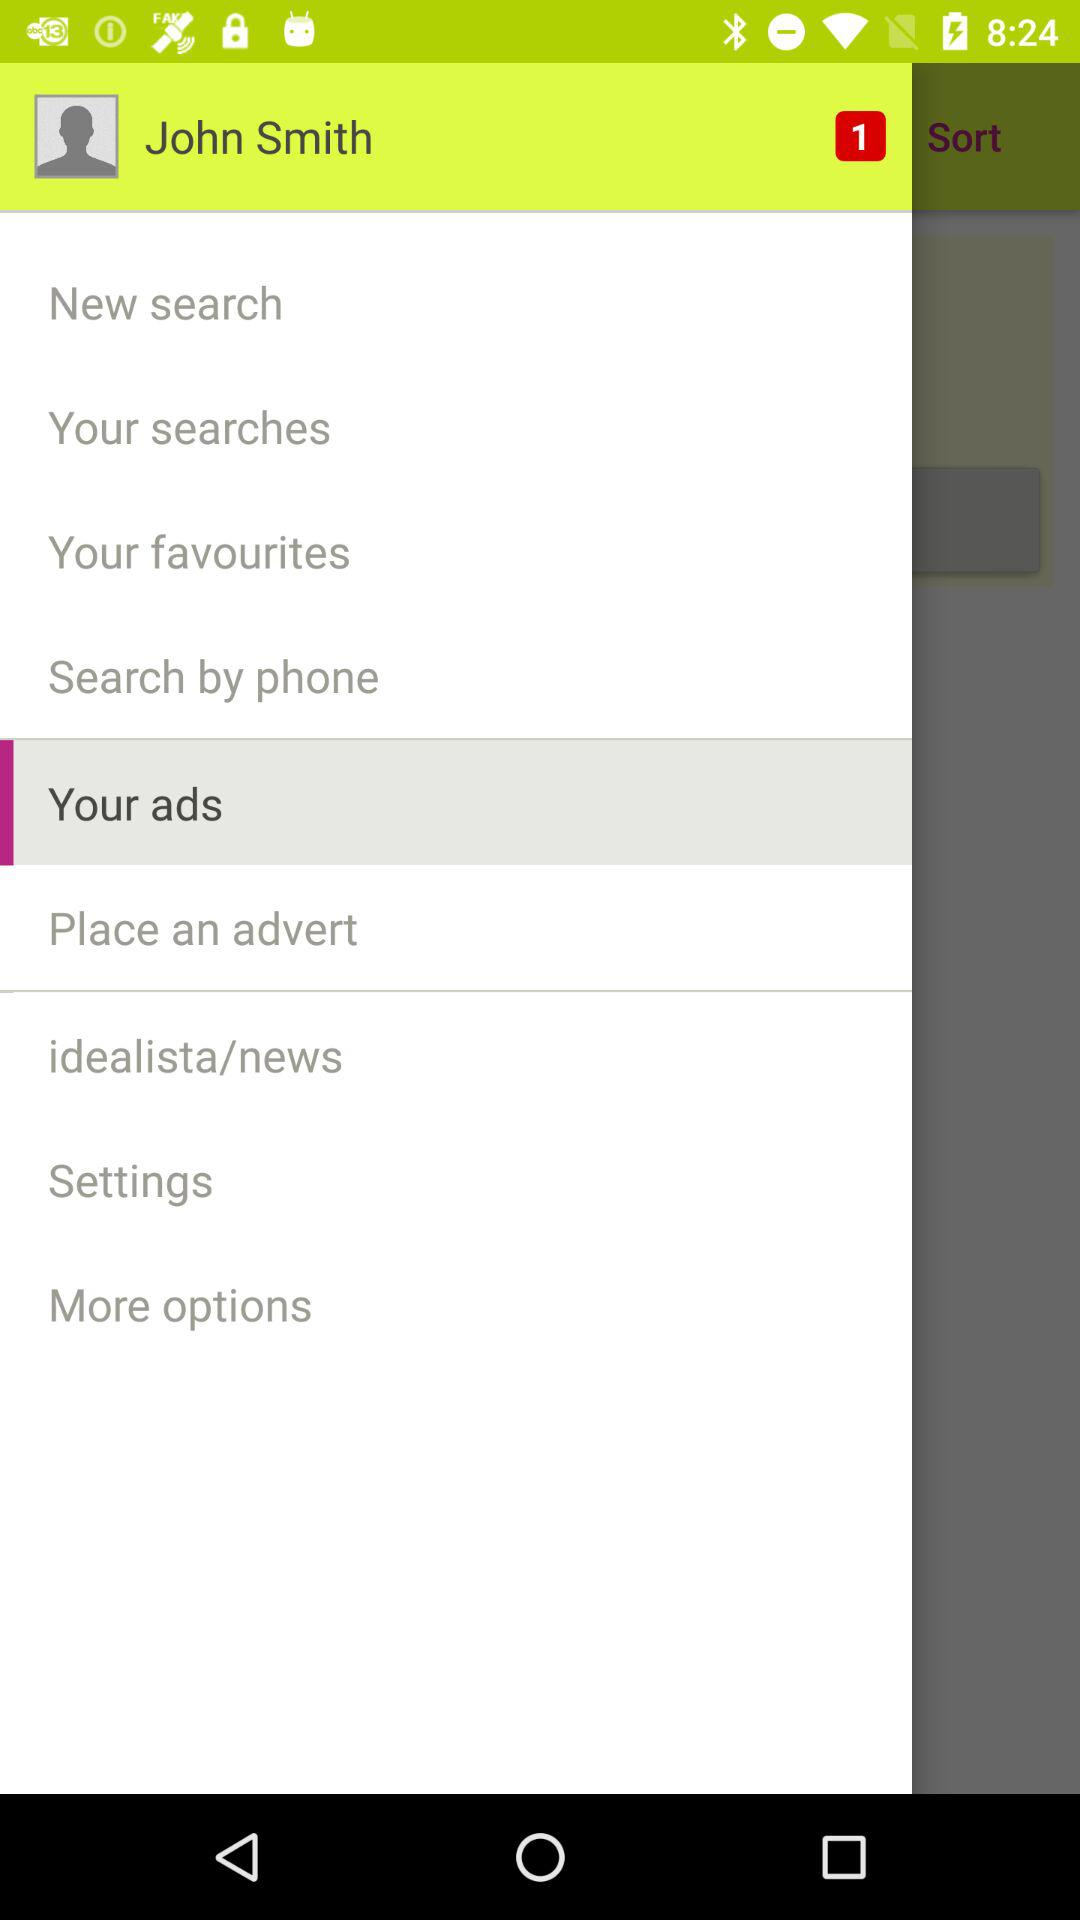What is the username? The username is John Smith. 